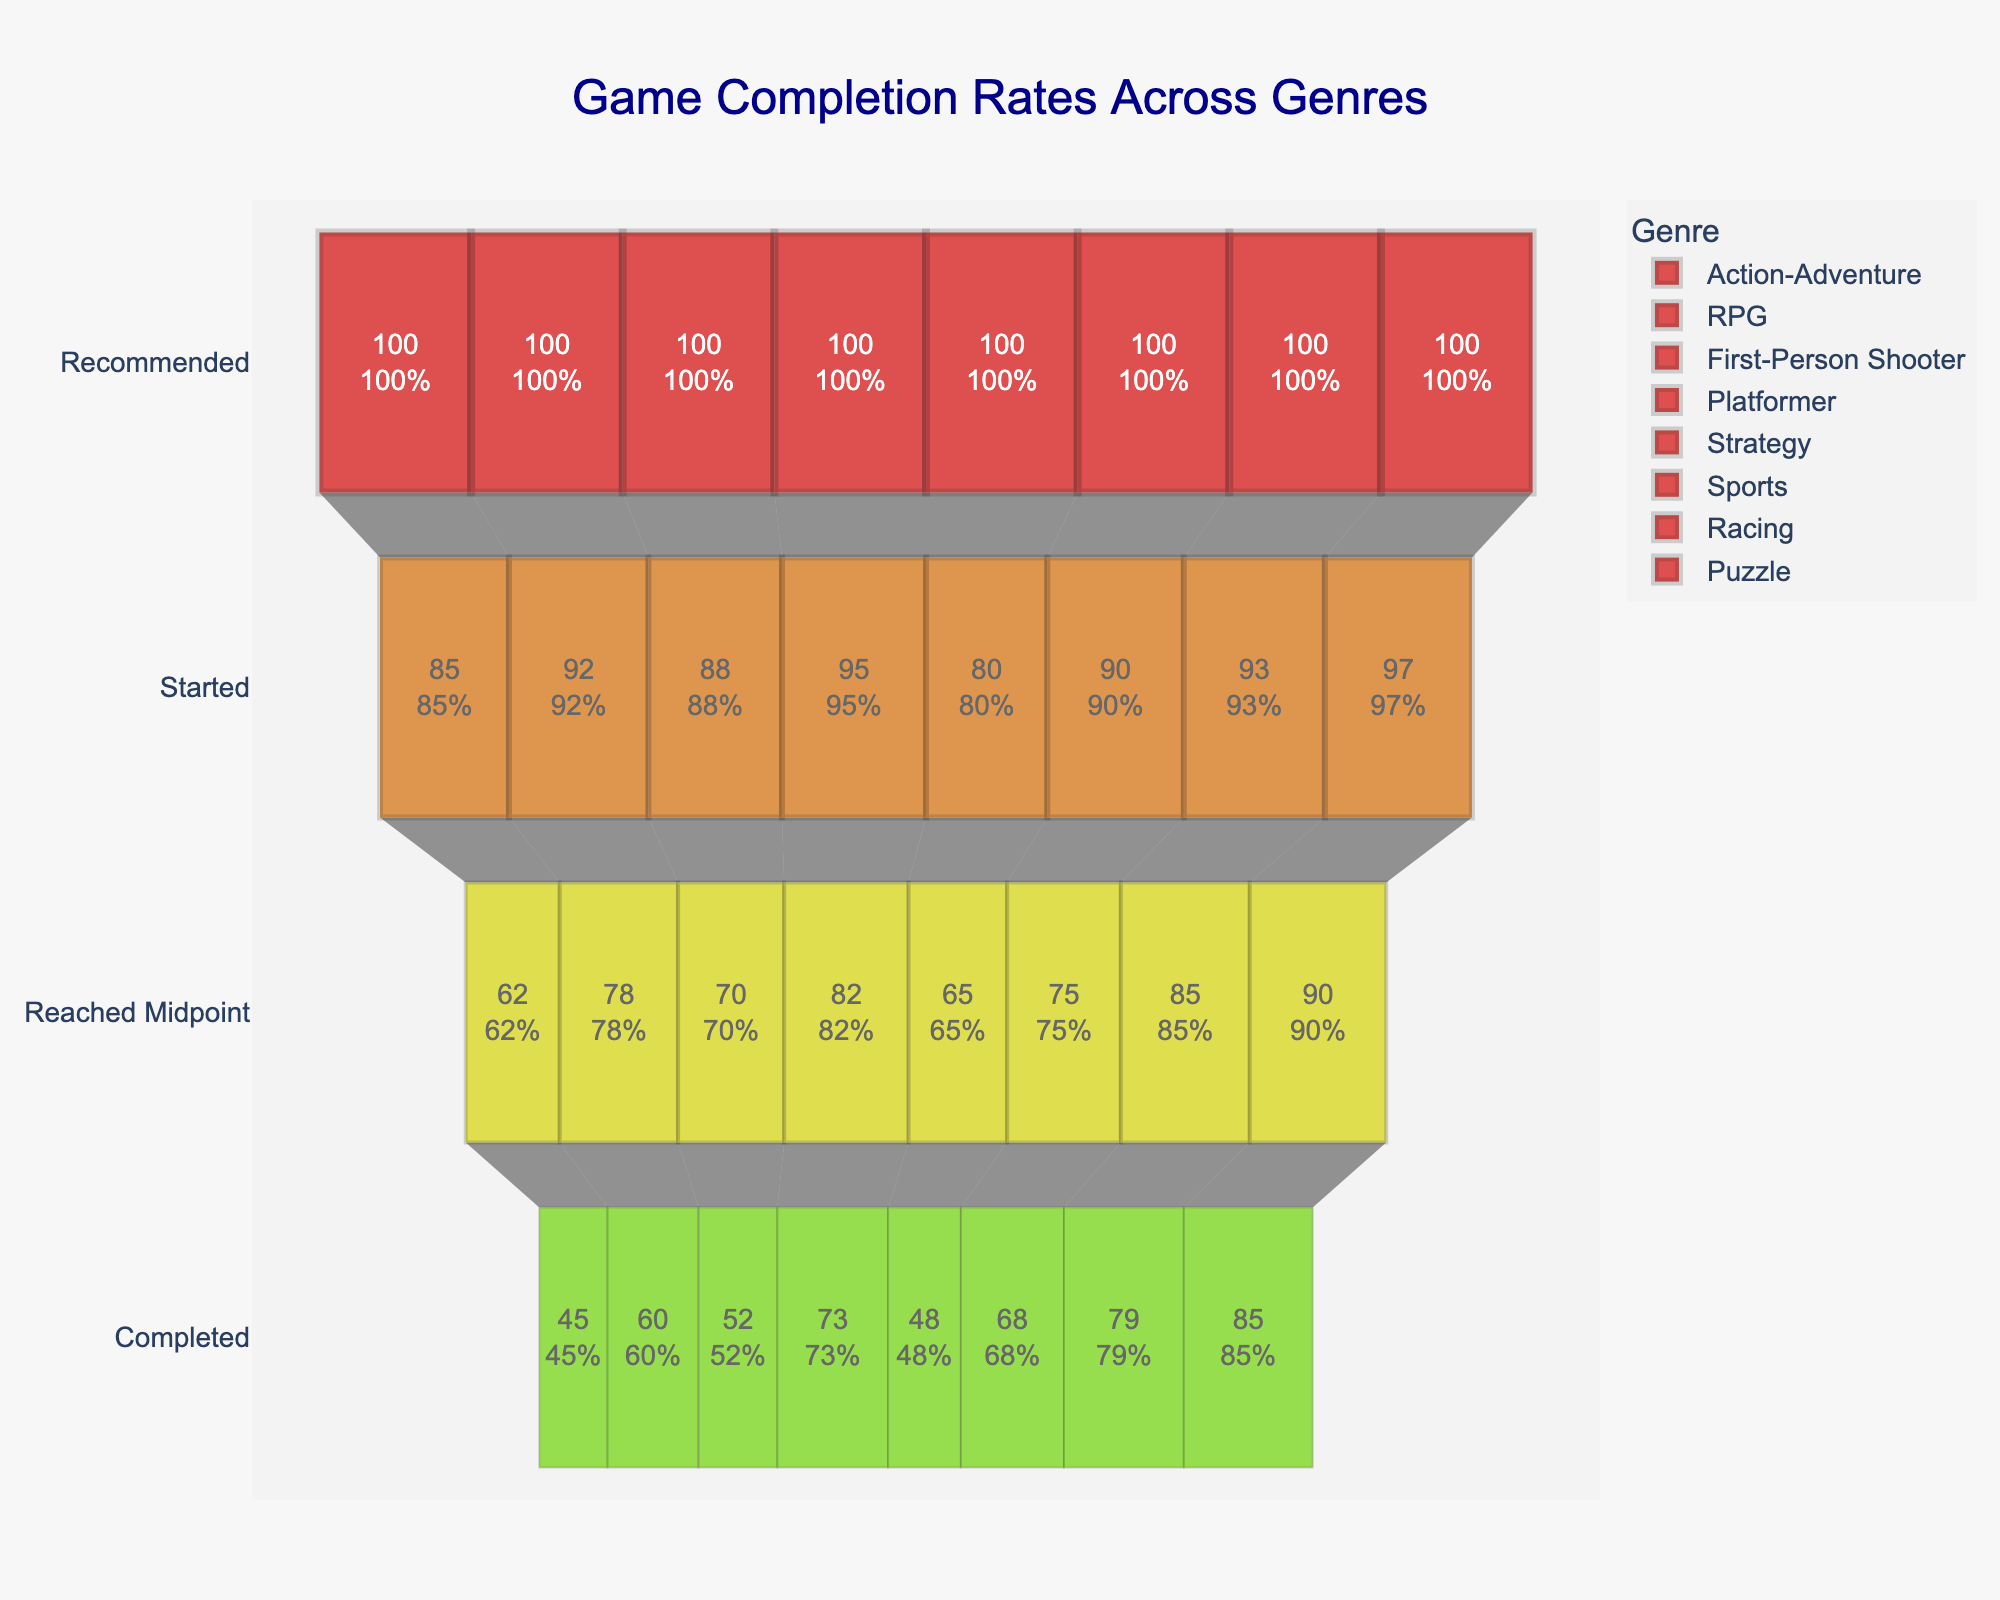What is the main title of the Funnel Chart? The title is found at the top of the figure. It should summarize the main point of the chart.
Answer: Game Completion Rates Across Genres Which genre has the largest drop from 'Started' to 'Reached Midpoint'? Determine the difference between 'Started' and 'Reached Midpoint' for each genre and identify the genre with the largest difference. For example, for Action-Adventure, the drop is 85 - 62 = 23.
Answer: First-Person Shooter What is the least completed genre? Look at the 'Completed' section for each genre and identify the one with the smallest number.
Answer: Strategy How many genres have more than 80 games 'Reached Midpoint'? Count the genres where the 'Reached Midpoint' value is greater than 80. For example, count those like RPG with 78.
Answer: Two Between 'Platformer' and 'Racing', which genre has a higher 'Started' count? Compare the 'Started' values of 'Platformer' and 'Racing'. Platformer has 95 and Racing has 93.
Answer: Platformer What is the completion rate (in percent) for the 'Puzzle' genre? The completion rate can be calculated by dividing the 'Completed' value by 'Recommended' and multiplying by 100. For Puzzle, (85 / 100) * 100 = 85%.
Answer: 85% Which genre shows the most significant retention from 'Recommended' to 'Started'? Determine the retention by calculating the percentage of 'Started' out of 'Recommended' for each genre. The one with the highest percentage shows the most significant retention.
Answer: Puzzle Compare the completion rates between 'Action-Adventure' and 'Sports'. Which one is higher? Calculate the completion rates for both genres. For Action-Adventure, it's (45/100)*100 = 45%. For Sports, (68/100)*100 = 68%.
Answer: Sports How many games, on average, are completed across all genres? Add the 'Completed' values of all genres and divide by the number of genres. Sum = 45 + 60 + 52 + 73 + 48 + 68 + 79 + 85 = 510. Average = 510/8 = 63.75.
Answer: 63.75 What's the difference in the number of games 'Started' between 'RPG' and 'Strategy'? Subtract the 'Started' value of Strategy from RPG. 92 - 80 = 12.
Answer: 12 